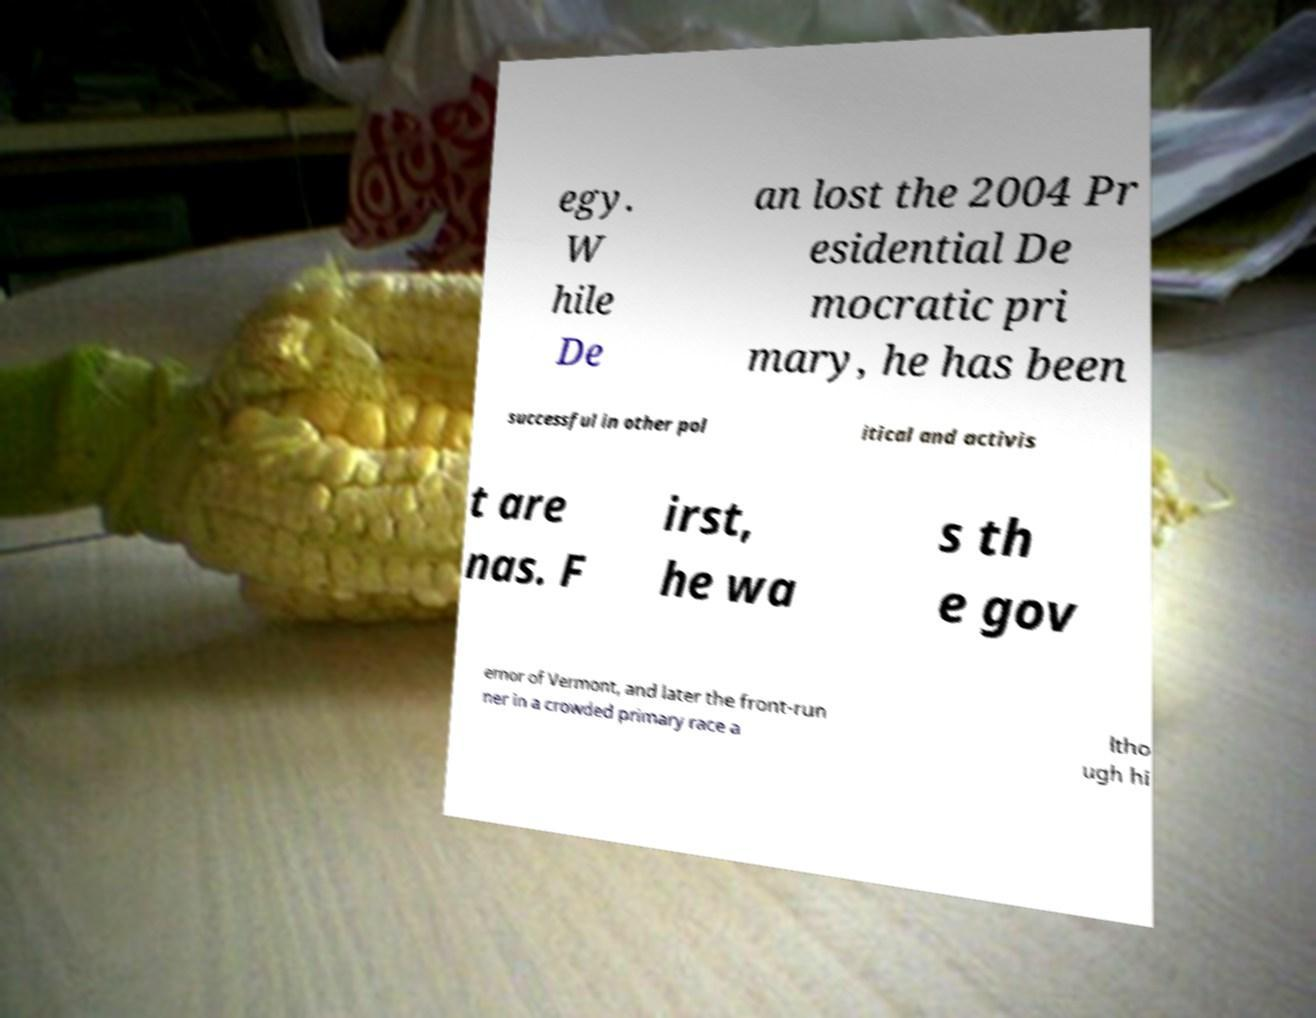Can you read and provide the text displayed in the image?This photo seems to have some interesting text. Can you extract and type it out for me? egy. W hile De an lost the 2004 Pr esidential De mocratic pri mary, he has been successful in other pol itical and activis t are nas. F irst, he wa s th e gov ernor of Vermont, and later the front-run ner in a crowded primary race a ltho ugh hi 